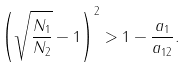Convert formula to latex. <formula><loc_0><loc_0><loc_500><loc_500>\left ( \sqrt { \frac { N _ { 1 } } { N _ { 2 } } } - 1 \right ) ^ { 2 } > 1 - \frac { a _ { 1 } } { a _ { 1 2 } } .</formula> 